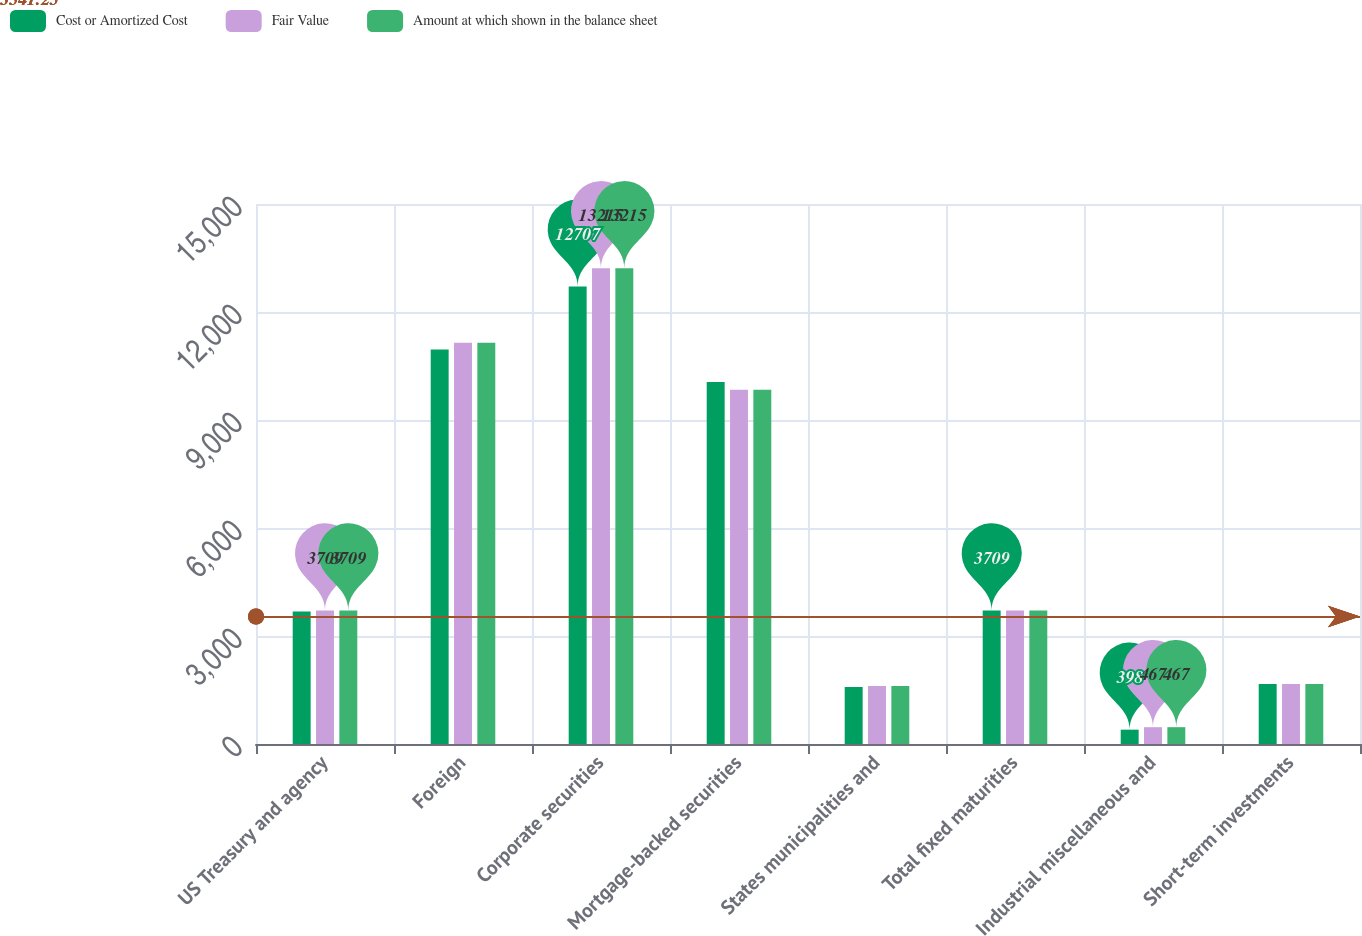Convert chart to OTSL. <chart><loc_0><loc_0><loc_500><loc_500><stacked_bar_chart><ecel><fcel>US Treasury and agency<fcel>Foreign<fcel>Corporate securities<fcel>Mortgage-backed securities<fcel>States municipalities and<fcel>Total fixed maturities<fcel>Industrial miscellaneous and<fcel>Short-term investments<nl><fcel>Cost or Amortized Cost<fcel>3680<fcel>10960<fcel>12707<fcel>10058<fcel>1580<fcel>3709<fcel>398<fcel>1667<nl><fcel>Fair Value<fcel>3709<fcel>11145<fcel>13215<fcel>9842<fcel>1614<fcel>3709<fcel>467<fcel>1667<nl><fcel>Amount at which shown in the balance sheet<fcel>3709<fcel>11145<fcel>13215<fcel>9842<fcel>1614<fcel>3709<fcel>467<fcel>1667<nl></chart> 